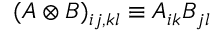Convert formula to latex. <formula><loc_0><loc_0><loc_500><loc_500>( A \otimes B ) _ { i j , k l } \equiv A _ { i k } B _ { j l }</formula> 